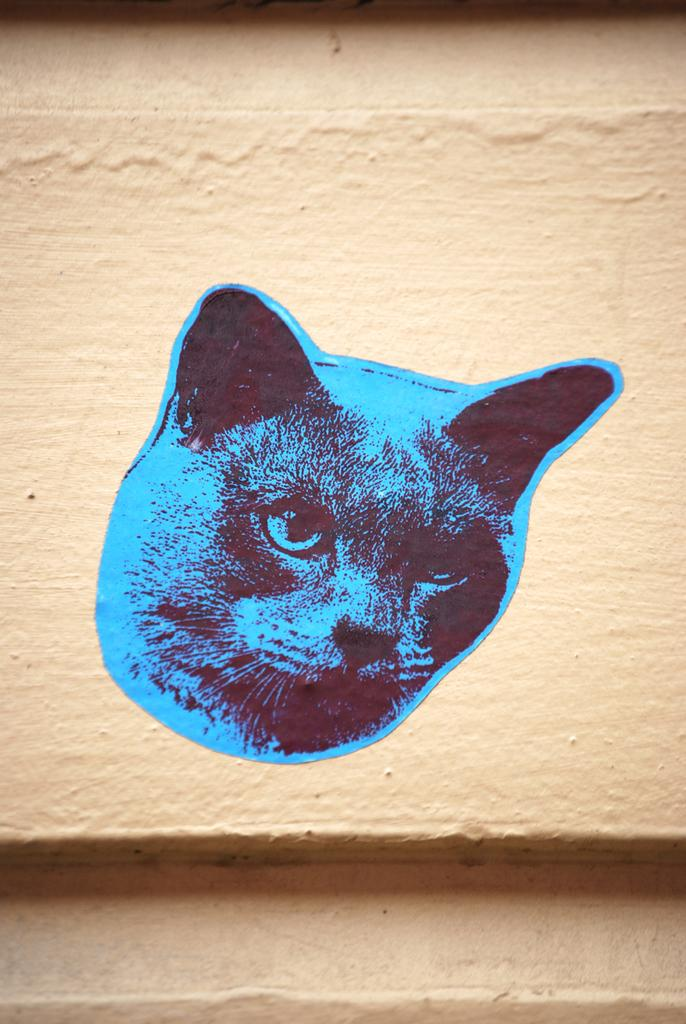What is depicted in the image? There is a photo of a cat in the image. Where is the photo of the cat located? The photo of the cat is pasted on a wall. What type of feast is being prepared in the image? There is no feast or any indication of food preparation in the image; it only features a photo of a cat on a wall. 